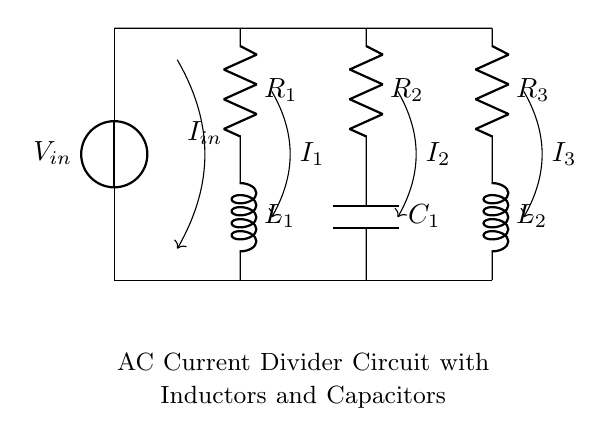What are the components present in the circuit? The circuit includes resistors, inductors, and capacitors, specifically three resistors (R1, R2, R3), two inductors (L1, L2), and one capacitor (C1).
Answer: resistors, inductors, capacitors What is the input voltage of the circuit? The input voltage is represented as V in the circuit diagram, which is the source connected at the top.
Answer: V What is the relationship between the currents I1, I2, and I3? The total input current Iin is divided among the branches with currents I1, I2, and I3 flowing through them, adhering to Kirchhoff’s current law which states that the sum of currents entering a junction equals the sum of currents leaving.
Answer: Iin = I1 + I2 + I3 Which branch contains the capacitor? The capacitor C1 is connected in parallel with the resistor R2 in the second branch of the circuit.
Answer: second branch How does adding inductors affect the total current divider behavior? Inductors introduce reactance to the circuit, which impacts the impedance of their respective branches, affecting the current division as the reactance changes with frequency in AC circuits, leading to different current distribution compared to purely resistive circuits.
Answer: alters current distribution What happens to the overall impedance of the circuit if one inductor is removed? Removing one inductor would decrease the overall impedance of the corresponding branch, potentially resulting in increased current through that branch according to the current divider principle, which states that lower impedance results in larger current flow through that path.
Answer: increases current through that branch 